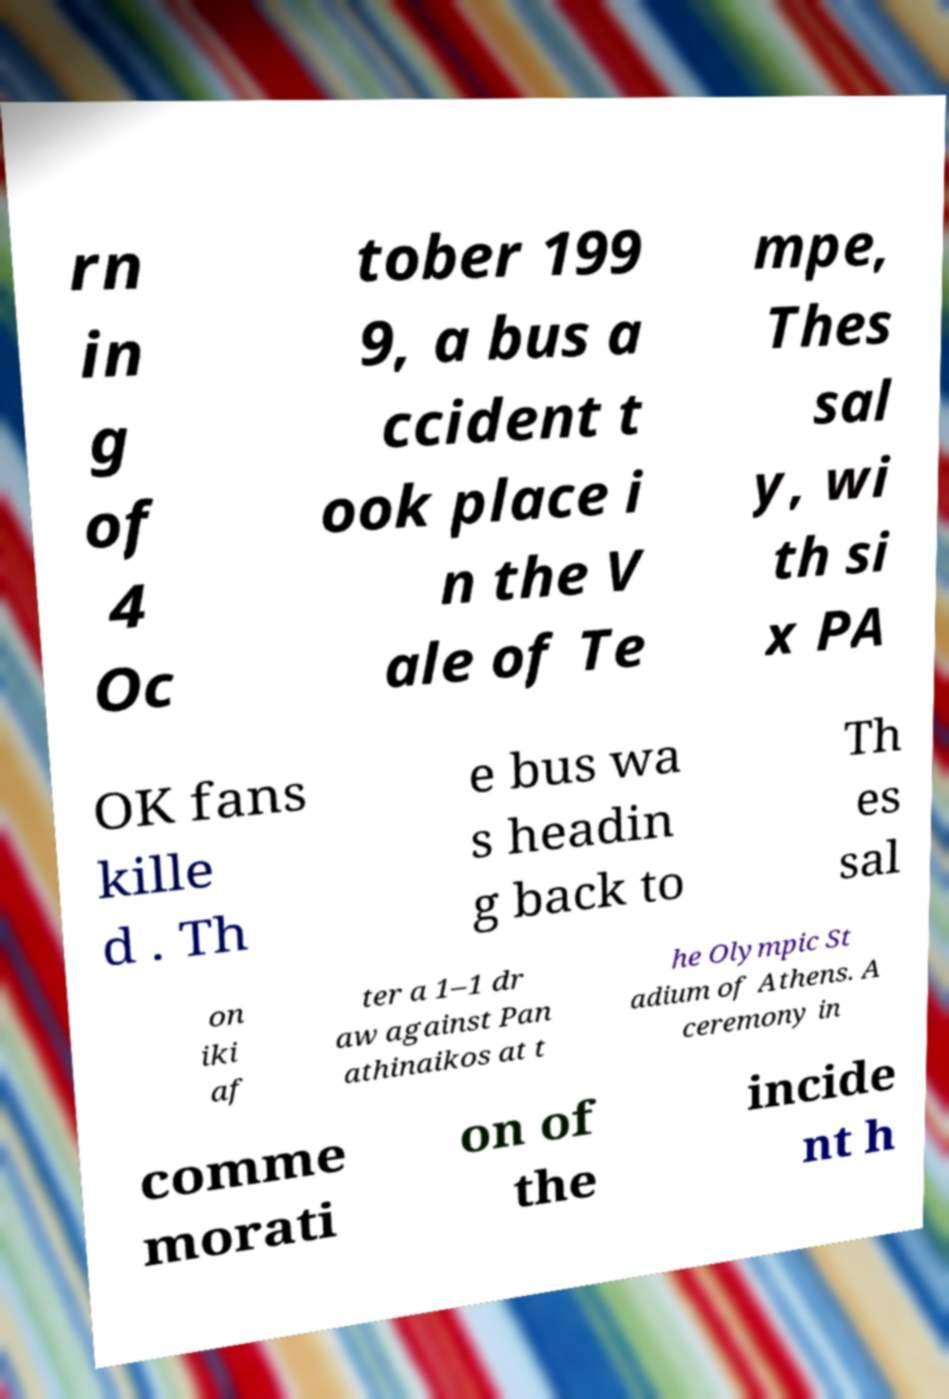Can you accurately transcribe the text from the provided image for me? rn in g of 4 Oc tober 199 9, a bus a ccident t ook place i n the V ale of Te mpe, Thes sal y, wi th si x PA OK fans kille d . Th e bus wa s headin g back to Th es sal on iki af ter a 1–1 dr aw against Pan athinaikos at t he Olympic St adium of Athens. A ceremony in comme morati on of the incide nt h 